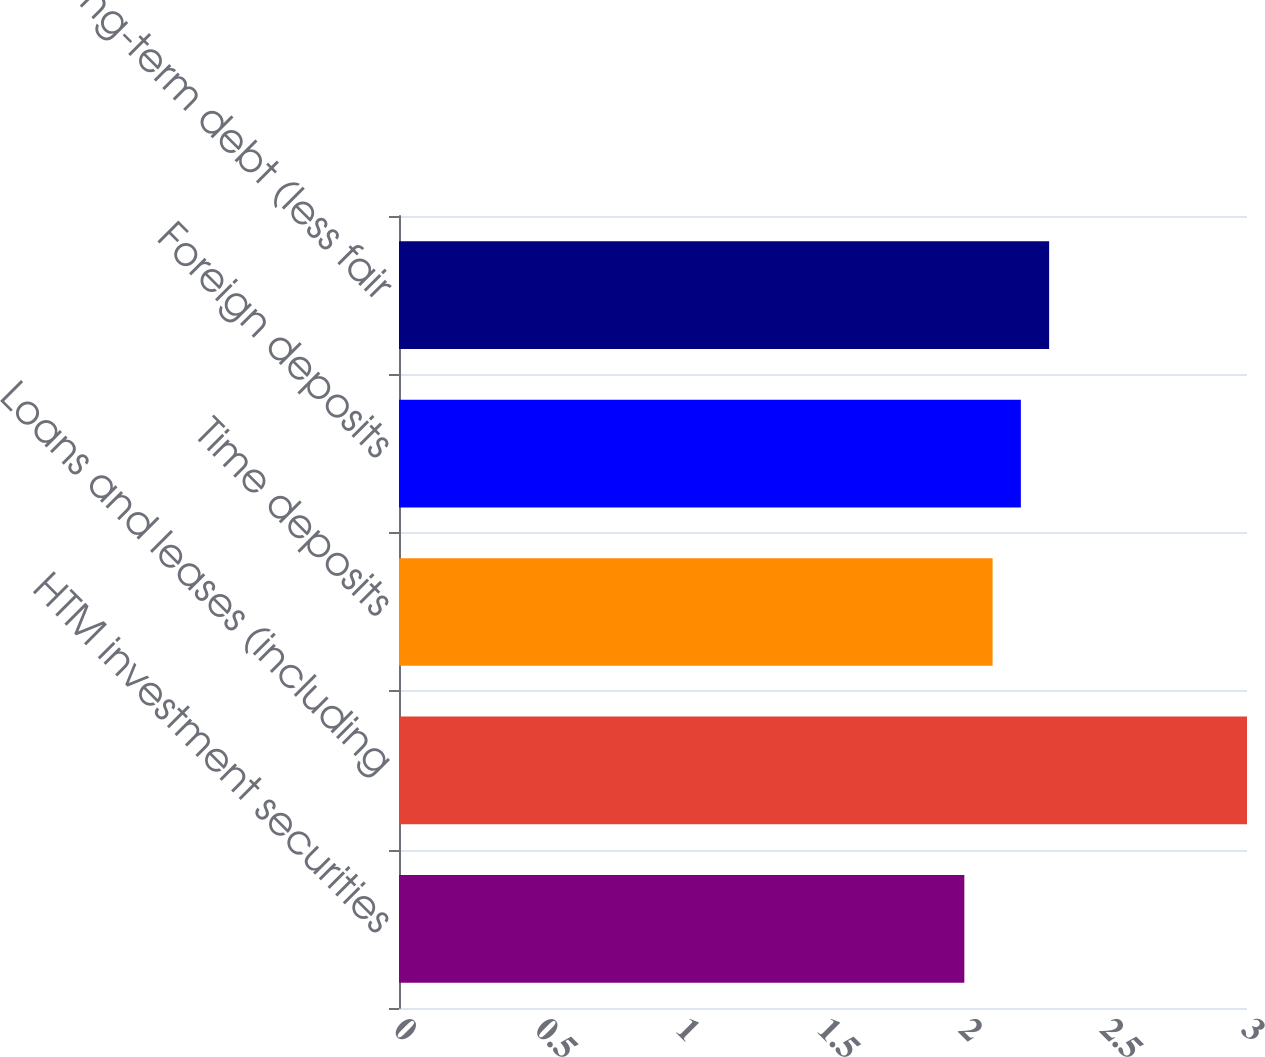Convert chart to OTSL. <chart><loc_0><loc_0><loc_500><loc_500><bar_chart><fcel>HTM investment securities<fcel>Loans and leases (including<fcel>Time deposits<fcel>Foreign deposits<fcel>Long-term debt (less fair<nl><fcel>2<fcel>3<fcel>2.1<fcel>2.2<fcel>2.3<nl></chart> 